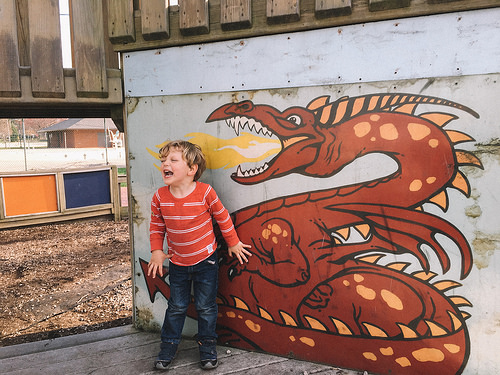<image>
Can you confirm if the dragon is behind the child? Yes. From this viewpoint, the dragon is positioned behind the child, with the child partially or fully occluding the dragon. 